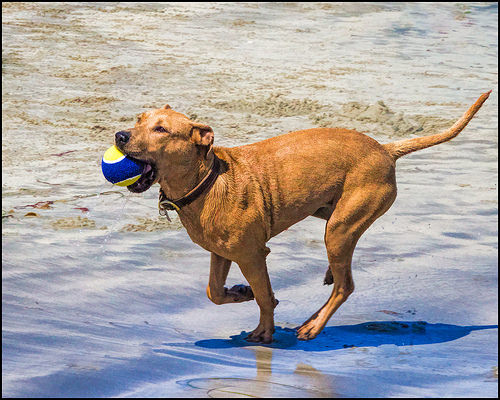<image>
Can you confirm if the ball is in the dog? Yes. The ball is contained within or inside the dog, showing a containment relationship. Is there a ball in the dog mouth? Yes. The ball is contained within or inside the dog mouth, showing a containment relationship. Where is the ball in relation to the dog? Is it above the dog? No. The ball is not positioned above the dog. The vertical arrangement shows a different relationship. 